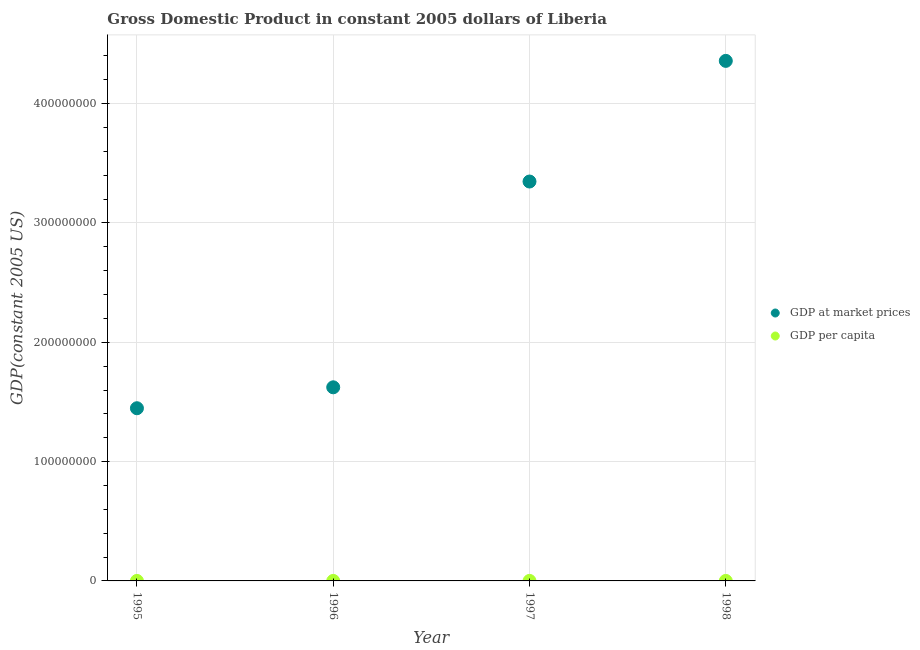What is the gdp at market prices in 1998?
Ensure brevity in your answer.  4.36e+08. Across all years, what is the maximum gdp at market prices?
Ensure brevity in your answer.  4.36e+08. Across all years, what is the minimum gdp at market prices?
Offer a terse response. 1.45e+08. In which year was the gdp at market prices maximum?
Your response must be concise. 1998. What is the total gdp per capita in the graph?
Your response must be concise. 455.29. What is the difference between the gdp per capita in 1996 and that in 1998?
Offer a very short reply. -96.54. What is the difference between the gdp per capita in 1997 and the gdp at market prices in 1996?
Provide a succinct answer. -1.62e+08. What is the average gdp per capita per year?
Provide a succinct answer. 113.82. In the year 1995, what is the difference between the gdp at market prices and gdp per capita?
Offer a very short reply. 1.45e+08. In how many years, is the gdp at market prices greater than 60000000 US$?
Your answer should be very brief. 4. What is the ratio of the gdp per capita in 1996 to that in 1998?
Your answer should be compact. 0.43. What is the difference between the highest and the second highest gdp at market prices?
Offer a terse response. 1.01e+08. What is the difference between the highest and the lowest gdp per capita?
Your response must be concise. 100.79. In how many years, is the gdp at market prices greater than the average gdp at market prices taken over all years?
Provide a succinct answer. 2. How many dotlines are there?
Your answer should be very brief. 2. How many years are there in the graph?
Ensure brevity in your answer.  4. What is the difference between two consecutive major ticks on the Y-axis?
Provide a succinct answer. 1.00e+08. Where does the legend appear in the graph?
Provide a short and direct response. Center right. How are the legend labels stacked?
Offer a very short reply. Vertical. What is the title of the graph?
Your answer should be compact. Gross Domestic Product in constant 2005 dollars of Liberia. Does "Health Care" appear as one of the legend labels in the graph?
Make the answer very short. No. What is the label or title of the Y-axis?
Provide a short and direct response. GDP(constant 2005 US). What is the GDP(constant 2005 US) in GDP at market prices in 1995?
Give a very brief answer. 1.45e+08. What is the GDP(constant 2005 US) of GDP per capita in 1995?
Your answer should be compact. 69.58. What is the GDP(constant 2005 US) in GDP at market prices in 1996?
Make the answer very short. 1.62e+08. What is the GDP(constant 2005 US) in GDP per capita in 1996?
Offer a very short reply. 73.83. What is the GDP(constant 2005 US) of GDP at market prices in 1997?
Offer a very short reply. 3.35e+08. What is the GDP(constant 2005 US) of GDP per capita in 1997?
Your answer should be compact. 141.51. What is the GDP(constant 2005 US) of GDP at market prices in 1998?
Your response must be concise. 4.36e+08. What is the GDP(constant 2005 US) in GDP per capita in 1998?
Offer a terse response. 170.37. Across all years, what is the maximum GDP(constant 2005 US) of GDP at market prices?
Give a very brief answer. 4.36e+08. Across all years, what is the maximum GDP(constant 2005 US) of GDP per capita?
Offer a terse response. 170.37. Across all years, what is the minimum GDP(constant 2005 US) of GDP at market prices?
Keep it short and to the point. 1.45e+08. Across all years, what is the minimum GDP(constant 2005 US) of GDP per capita?
Your answer should be very brief. 69.58. What is the total GDP(constant 2005 US) in GDP at market prices in the graph?
Offer a terse response. 1.08e+09. What is the total GDP(constant 2005 US) in GDP per capita in the graph?
Offer a very short reply. 455.29. What is the difference between the GDP(constant 2005 US) of GDP at market prices in 1995 and that in 1996?
Offer a terse response. -1.75e+07. What is the difference between the GDP(constant 2005 US) in GDP per capita in 1995 and that in 1996?
Your answer should be very brief. -4.25. What is the difference between the GDP(constant 2005 US) in GDP at market prices in 1995 and that in 1997?
Ensure brevity in your answer.  -1.90e+08. What is the difference between the GDP(constant 2005 US) in GDP per capita in 1995 and that in 1997?
Your answer should be compact. -71.93. What is the difference between the GDP(constant 2005 US) of GDP at market prices in 1995 and that in 1998?
Your response must be concise. -2.91e+08. What is the difference between the GDP(constant 2005 US) in GDP per capita in 1995 and that in 1998?
Offer a terse response. -100.79. What is the difference between the GDP(constant 2005 US) of GDP at market prices in 1996 and that in 1997?
Offer a very short reply. -1.72e+08. What is the difference between the GDP(constant 2005 US) of GDP per capita in 1996 and that in 1997?
Offer a very short reply. -67.68. What is the difference between the GDP(constant 2005 US) in GDP at market prices in 1996 and that in 1998?
Your response must be concise. -2.74e+08. What is the difference between the GDP(constant 2005 US) in GDP per capita in 1996 and that in 1998?
Your response must be concise. -96.54. What is the difference between the GDP(constant 2005 US) of GDP at market prices in 1997 and that in 1998?
Offer a very short reply. -1.01e+08. What is the difference between the GDP(constant 2005 US) of GDP per capita in 1997 and that in 1998?
Your response must be concise. -28.86. What is the difference between the GDP(constant 2005 US) in GDP at market prices in 1995 and the GDP(constant 2005 US) in GDP per capita in 1996?
Make the answer very short. 1.45e+08. What is the difference between the GDP(constant 2005 US) of GDP at market prices in 1995 and the GDP(constant 2005 US) of GDP per capita in 1997?
Give a very brief answer. 1.45e+08. What is the difference between the GDP(constant 2005 US) in GDP at market prices in 1995 and the GDP(constant 2005 US) in GDP per capita in 1998?
Give a very brief answer. 1.45e+08. What is the difference between the GDP(constant 2005 US) of GDP at market prices in 1996 and the GDP(constant 2005 US) of GDP per capita in 1997?
Offer a terse response. 1.62e+08. What is the difference between the GDP(constant 2005 US) in GDP at market prices in 1996 and the GDP(constant 2005 US) in GDP per capita in 1998?
Provide a succinct answer. 1.62e+08. What is the difference between the GDP(constant 2005 US) in GDP at market prices in 1997 and the GDP(constant 2005 US) in GDP per capita in 1998?
Offer a very short reply. 3.35e+08. What is the average GDP(constant 2005 US) of GDP at market prices per year?
Offer a terse response. 2.69e+08. What is the average GDP(constant 2005 US) in GDP per capita per year?
Give a very brief answer. 113.82. In the year 1995, what is the difference between the GDP(constant 2005 US) of GDP at market prices and GDP(constant 2005 US) of GDP per capita?
Make the answer very short. 1.45e+08. In the year 1996, what is the difference between the GDP(constant 2005 US) in GDP at market prices and GDP(constant 2005 US) in GDP per capita?
Provide a short and direct response. 1.62e+08. In the year 1997, what is the difference between the GDP(constant 2005 US) in GDP at market prices and GDP(constant 2005 US) in GDP per capita?
Ensure brevity in your answer.  3.35e+08. In the year 1998, what is the difference between the GDP(constant 2005 US) in GDP at market prices and GDP(constant 2005 US) in GDP per capita?
Offer a very short reply. 4.36e+08. What is the ratio of the GDP(constant 2005 US) of GDP at market prices in 1995 to that in 1996?
Provide a succinct answer. 0.89. What is the ratio of the GDP(constant 2005 US) in GDP per capita in 1995 to that in 1996?
Ensure brevity in your answer.  0.94. What is the ratio of the GDP(constant 2005 US) of GDP at market prices in 1995 to that in 1997?
Offer a very short reply. 0.43. What is the ratio of the GDP(constant 2005 US) of GDP per capita in 1995 to that in 1997?
Ensure brevity in your answer.  0.49. What is the ratio of the GDP(constant 2005 US) of GDP at market prices in 1995 to that in 1998?
Ensure brevity in your answer.  0.33. What is the ratio of the GDP(constant 2005 US) of GDP per capita in 1995 to that in 1998?
Ensure brevity in your answer.  0.41. What is the ratio of the GDP(constant 2005 US) in GDP at market prices in 1996 to that in 1997?
Make the answer very short. 0.48. What is the ratio of the GDP(constant 2005 US) in GDP per capita in 1996 to that in 1997?
Provide a succinct answer. 0.52. What is the ratio of the GDP(constant 2005 US) of GDP at market prices in 1996 to that in 1998?
Your answer should be compact. 0.37. What is the ratio of the GDP(constant 2005 US) of GDP per capita in 1996 to that in 1998?
Provide a short and direct response. 0.43. What is the ratio of the GDP(constant 2005 US) of GDP at market prices in 1997 to that in 1998?
Your answer should be compact. 0.77. What is the ratio of the GDP(constant 2005 US) in GDP per capita in 1997 to that in 1998?
Ensure brevity in your answer.  0.83. What is the difference between the highest and the second highest GDP(constant 2005 US) of GDP at market prices?
Keep it short and to the point. 1.01e+08. What is the difference between the highest and the second highest GDP(constant 2005 US) in GDP per capita?
Provide a succinct answer. 28.86. What is the difference between the highest and the lowest GDP(constant 2005 US) of GDP at market prices?
Your answer should be very brief. 2.91e+08. What is the difference between the highest and the lowest GDP(constant 2005 US) of GDP per capita?
Your response must be concise. 100.79. 